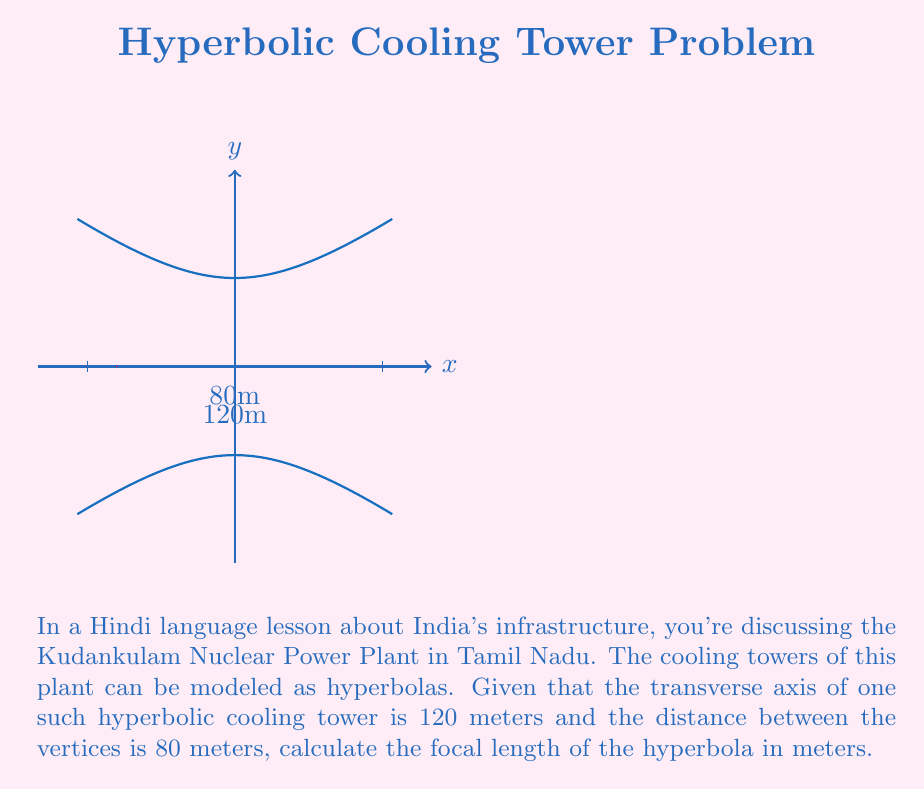Show me your answer to this math problem. Let's approach this step-by-step:

1) The equation of a hyperbola with center at the origin is:

   $$\frac{x^2}{a^2} - \frac{y^2}{b^2} = 1$$

   where $a$ is the distance from the center to a vertex, and $c$ is the distance from the center to a focus.

2) We're given that the distance between vertices is 80 meters. This means that $2a = 80$, or $a = 40$ meters.

3) We're also told that the transverse axis is 120 meters. This is the distance between the two foci, which equals $2c$.

   So, $2c = 120$, or $c = 60$ meters.

4) The focal length is defined as the distance from the center to a focus, which is $c$.

5) We can verify this using the hyperbola equation:

   $$c^2 = a^2 + b^2$$

   $$60^2 = 40^2 + b^2$$

   $$3600 = 1600 + b^2$$

   $$b^2 = 2000$$

   $$b = \sqrt{2000} \approx 44.72$$

6) This confirms our calculation, as $c = 60$ satisfies the equation.

Therefore, the focal length of the hyperbola is 60 meters.
Answer: 60 meters 